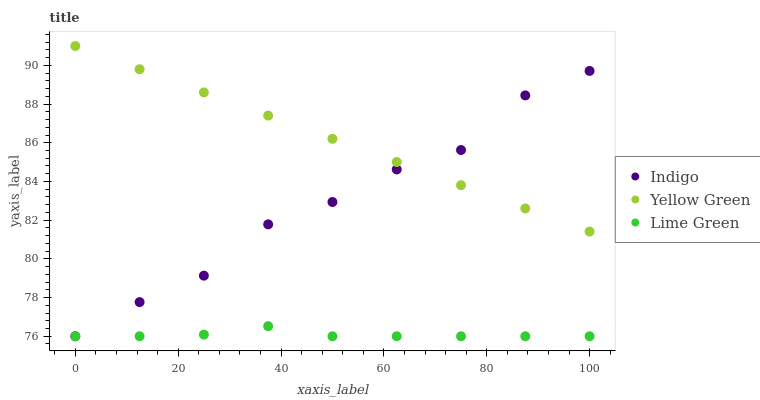Does Lime Green have the minimum area under the curve?
Answer yes or no. Yes. Does Yellow Green have the maximum area under the curve?
Answer yes or no. Yes. Does Indigo have the minimum area under the curve?
Answer yes or no. No. Does Indigo have the maximum area under the curve?
Answer yes or no. No. Is Yellow Green the smoothest?
Answer yes or no. Yes. Is Indigo the roughest?
Answer yes or no. Yes. Is Indigo the smoothest?
Answer yes or no. No. Is Yellow Green the roughest?
Answer yes or no. No. Does Lime Green have the lowest value?
Answer yes or no. Yes. Does Yellow Green have the lowest value?
Answer yes or no. No. Does Yellow Green have the highest value?
Answer yes or no. Yes. Does Indigo have the highest value?
Answer yes or no. No. Is Lime Green less than Yellow Green?
Answer yes or no. Yes. Is Yellow Green greater than Lime Green?
Answer yes or no. Yes. Does Lime Green intersect Indigo?
Answer yes or no. Yes. Is Lime Green less than Indigo?
Answer yes or no. No. Is Lime Green greater than Indigo?
Answer yes or no. No. Does Lime Green intersect Yellow Green?
Answer yes or no. No. 